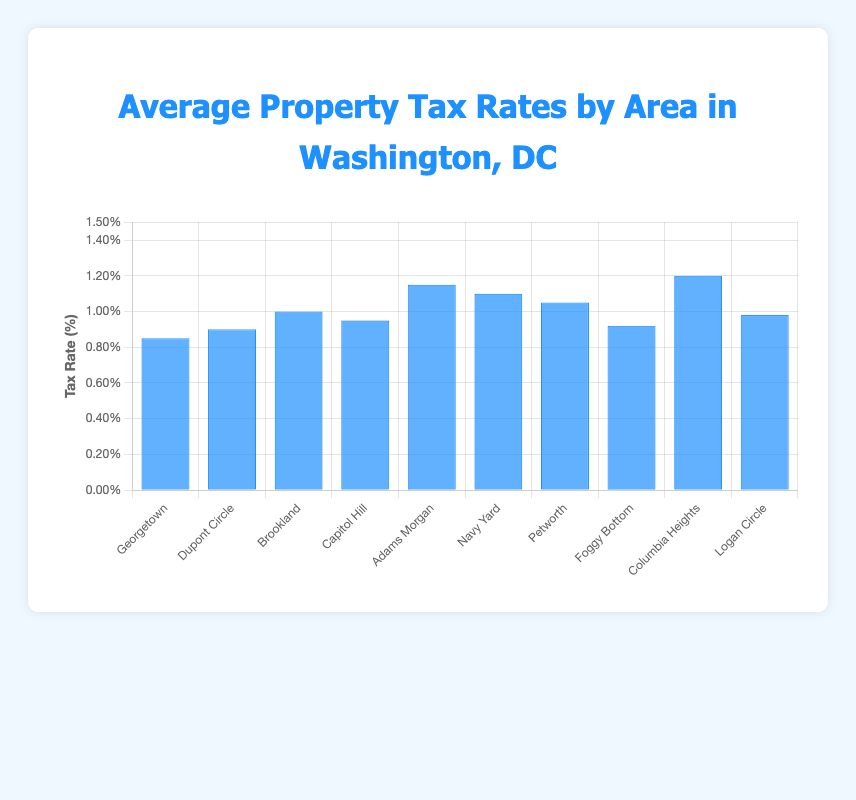What area has the highest average property tax rate? By looking at the bar heights, Columbia Heights has the tallest bar, indicating the highest property tax rate at 1.20%.
Answer: Columbia Heights Which area has the lowest average property tax rate? Georgetown has the shortest bar with an average property tax rate of 0.85%.
Answer: Georgetown What is the average property tax rate for Dupont Circle? The bar for Dupont Circle shows an average property tax rate of 0.90%.
Answer: 0.90% How many areas have an average property tax rate equal to or above 1.00%? By counting the bars with heights equal to or higher than 1.00%, the areas are Brookland, Adams Morgan, Navy Yard, Petworth, and Columbia Heights, making it 5 areas.
Answer: 5 What is the difference in average property tax rates between Adams Morgan and Navy Yard? The average property tax rate for Adams Morgan is 1.15% and for Navy Yard is 1.10%. The difference is 1.15% - 1.10% = 0.05%.
Answer: 0.05% What is the average property tax rate for the first three areas (Georgetown, Dupont Circle, and Brookland)? Add the tax rates of the first three areas and divide by 3: (0.85 + 0.90 + 1.00) / 3 = 2.75 / 3 = 0.92%.
Answer: 0.92% How many areas have a higher average property tax rate than Logan Circle? Logan Circle has an average tax rate of 0.98%. The areas with higher rates are Brookland, Capitol Hill, Adams Morgan, Navy Yard, Petworth, and Columbia Heights, making it 6 areas.
Answer: 6 Which has a higher average property tax rate, Capitol Hill or Petworth? The bar for Petworth is taller than that of Capitol Hill. Petworth's rate is 1.05% and Capitol Hill's rate is 0.95%.
Answer: Petworth What is the median average property tax rate of all the areas? To find the median, list all the tax rates in ascending order and find the middle value: [0.85, 0.90, 0.92, 0.95, 0.98, 1.00, 1.05, 1.10, 1.15, 1.20]. The median is the average of 0.98 and 1.00, so (0.98 + 1.00)/2 = 0.99%.
Answer: 0.99% Which area has an average property tax rate closest to the overall average of all areas? Calculate the overall average: (0.85+0.90+1.00+0.95+1.15+1.10+1.05+0.92+1.20+0.98)/10 = 1.01%. The closest rate is 1.00% in Brookland.
Answer: Brookland 